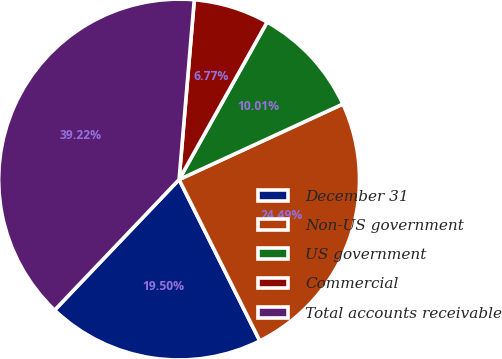Convert chart. <chart><loc_0><loc_0><loc_500><loc_500><pie_chart><fcel>December 31<fcel>Non-US government<fcel>US government<fcel>Commercial<fcel>Total accounts receivable<nl><fcel>19.5%<fcel>24.49%<fcel>10.01%<fcel>6.77%<fcel>39.22%<nl></chart> 